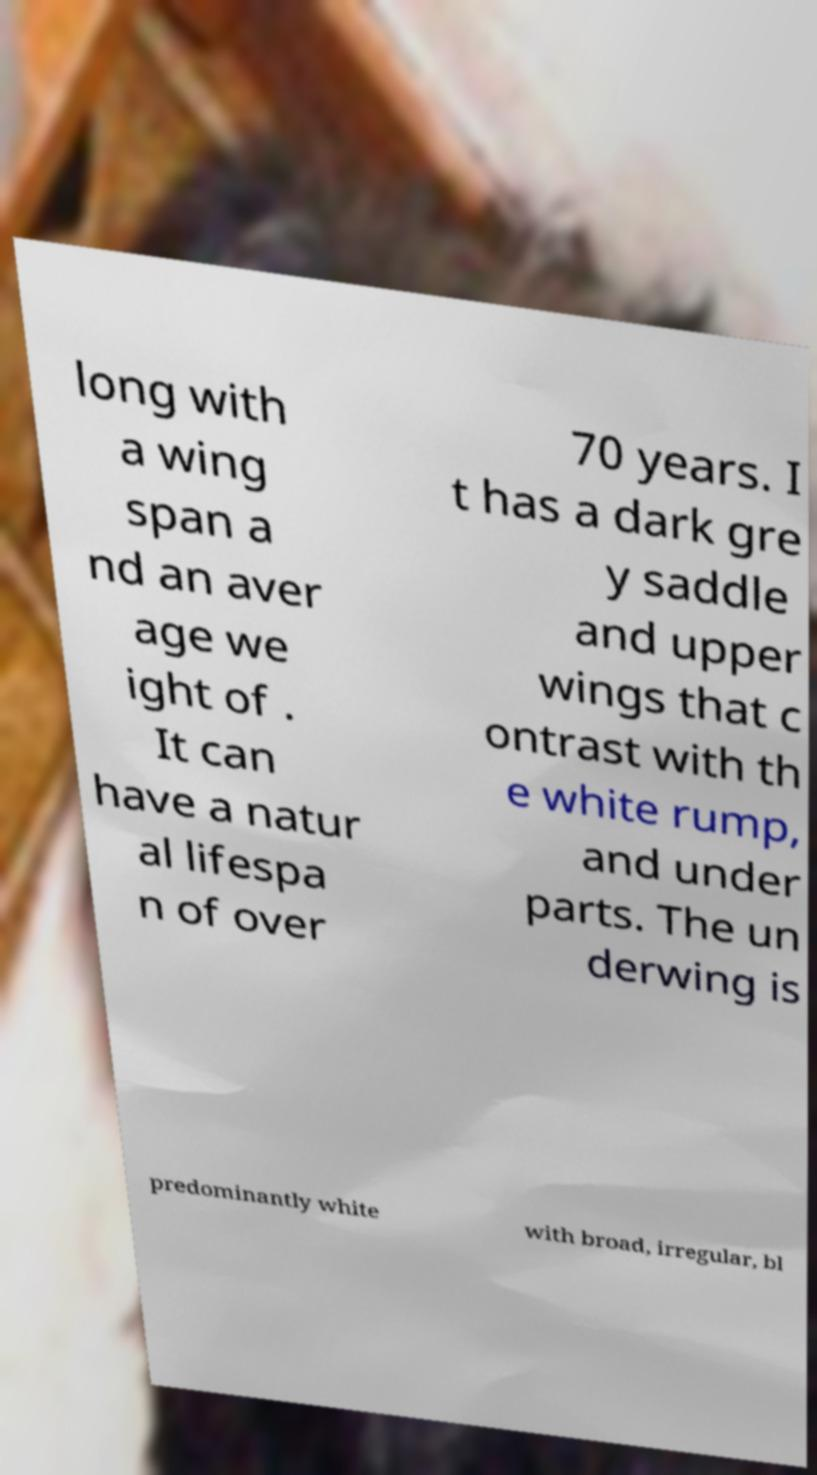Please identify and transcribe the text found in this image. long with a wing span a nd an aver age we ight of . It can have a natur al lifespa n of over 70 years. I t has a dark gre y saddle and upper wings that c ontrast with th e white rump, and under parts. The un derwing is predominantly white with broad, irregular, bl 